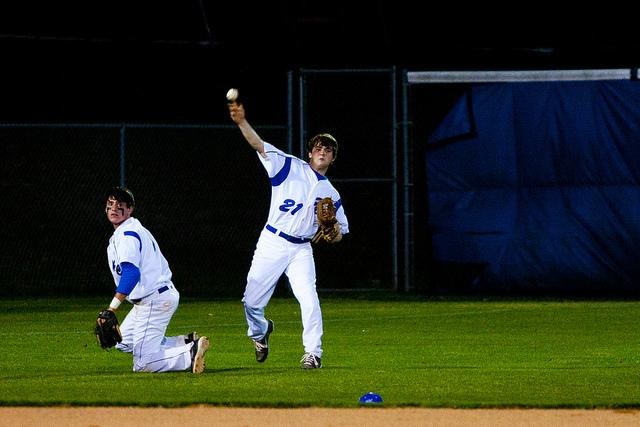What position is played by the kneeling player? catcher 